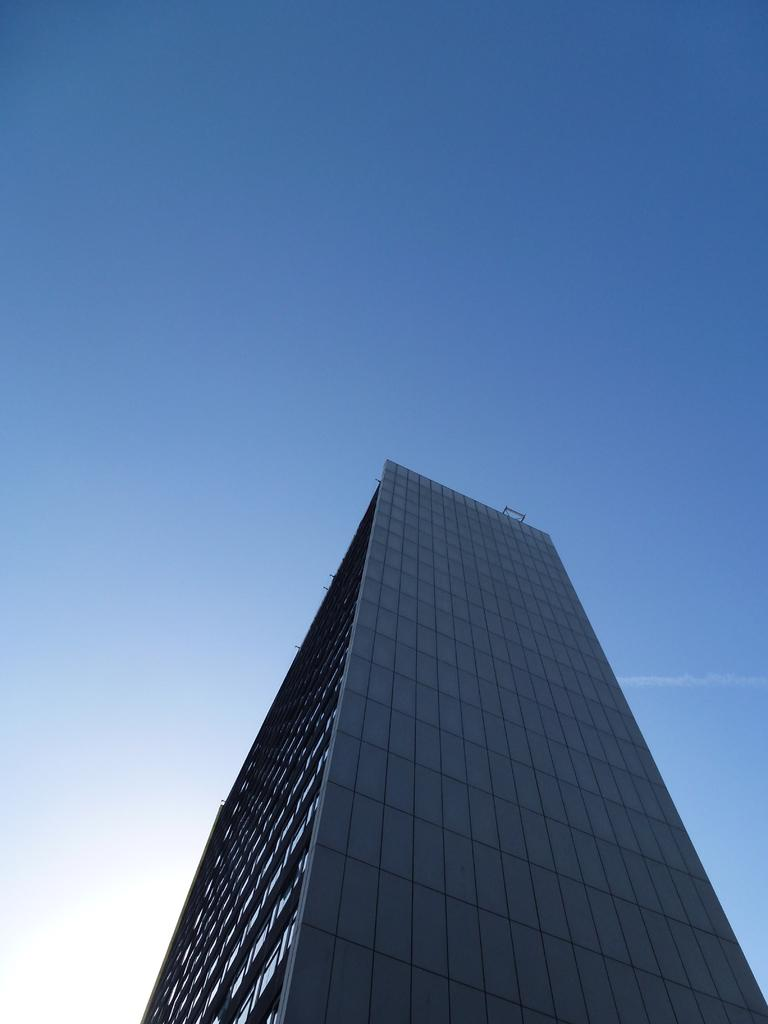What type of structure is present in the image? There is a tall building in the image. What can be seen in the background of the image? There is a sky visible in the background of the image. Can the sun be seen in the sky in the background of the image? Yes, the sun is observable in the sky in the background of the image. What type of store can be seen in the image? There is no store present in the image; it features a tall building and a sky with the sun visible. How does the building provide support in the image? The image does not show the building providing support; it only shows the building itself. 